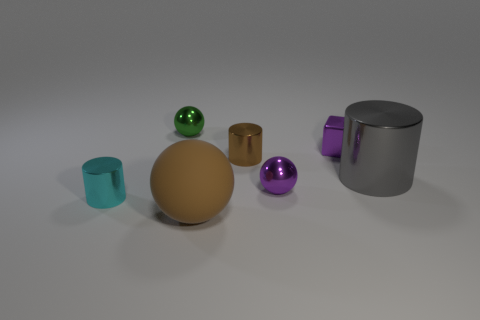Is the material of the cylinder to the left of the brown matte ball the same as the ball that is right of the large brown sphere?
Keep it short and to the point. Yes. The big object in front of the gray cylinder has what shape?
Your response must be concise. Sphere. Are there fewer large red rubber cylinders than brown metallic cylinders?
Make the answer very short. Yes. Are there any tiny cyan shiny things that are on the right side of the tiny shiny cylinder that is behind the metal cylinder to the right of the block?
Your response must be concise. No. What number of shiny things are yellow things or balls?
Give a very brief answer. 2. Is the color of the large shiny cylinder the same as the metallic block?
Ensure brevity in your answer.  No. There is a matte thing; how many tiny purple things are on the left side of it?
Provide a succinct answer. 0. What number of things are both to the left of the green object and in front of the cyan shiny cylinder?
Offer a very short reply. 0. There is a small brown object that is the same material as the purple cube; what is its shape?
Provide a succinct answer. Cylinder. There is a shiny ball that is to the right of the small brown thing; is its size the same as the green shiny object left of the large gray object?
Offer a very short reply. Yes. 